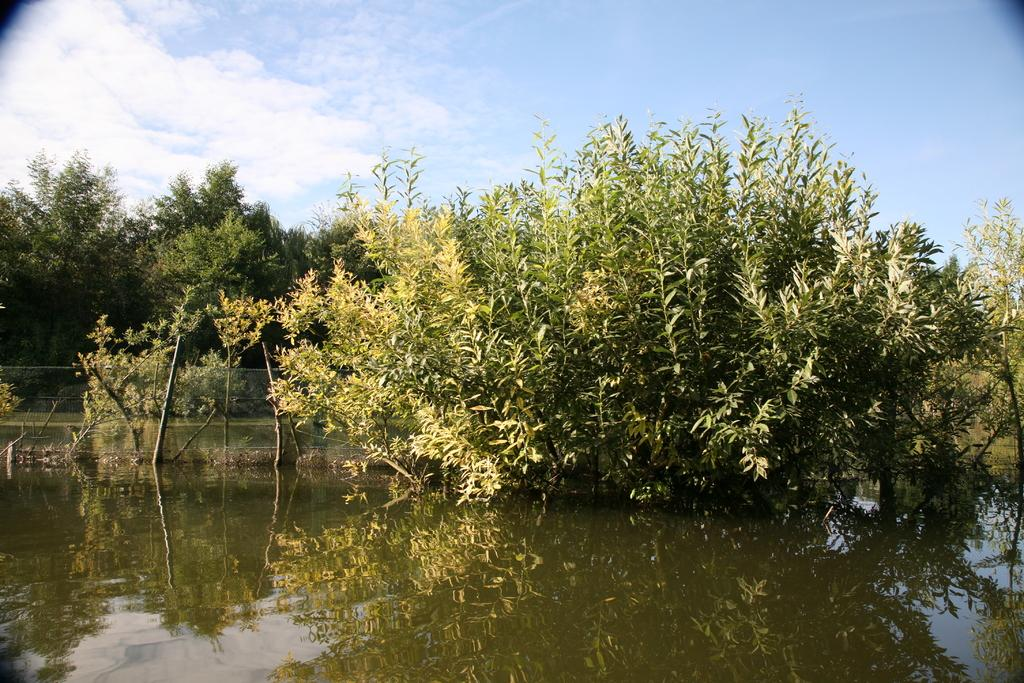What can be seen in the front portion of the image? In the front portion of the image, there is water, a fence, and trees. What is visible in the background of the image? The sky is visible in the background of the image. What is the condition of the sky in the image? The sky is cloudy in the image. What type of plastic is floating in the water in the image? There is no plastic visible in the water in the image. How does the bit of trouble affect the trees in the image? There is no mention of trouble or any negative impact on the trees in the image; the trees appear to be standing normally. 